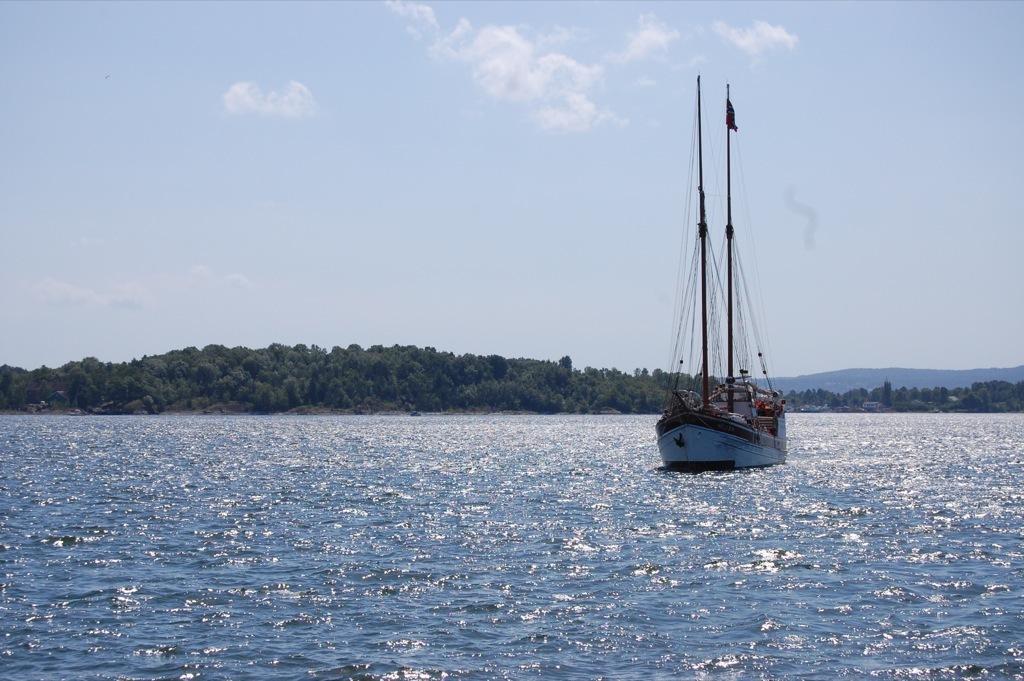In one or two sentences, can you explain what this image depicts? In this picture we can see a boat on the water. In the background we can see trees and the sky. 